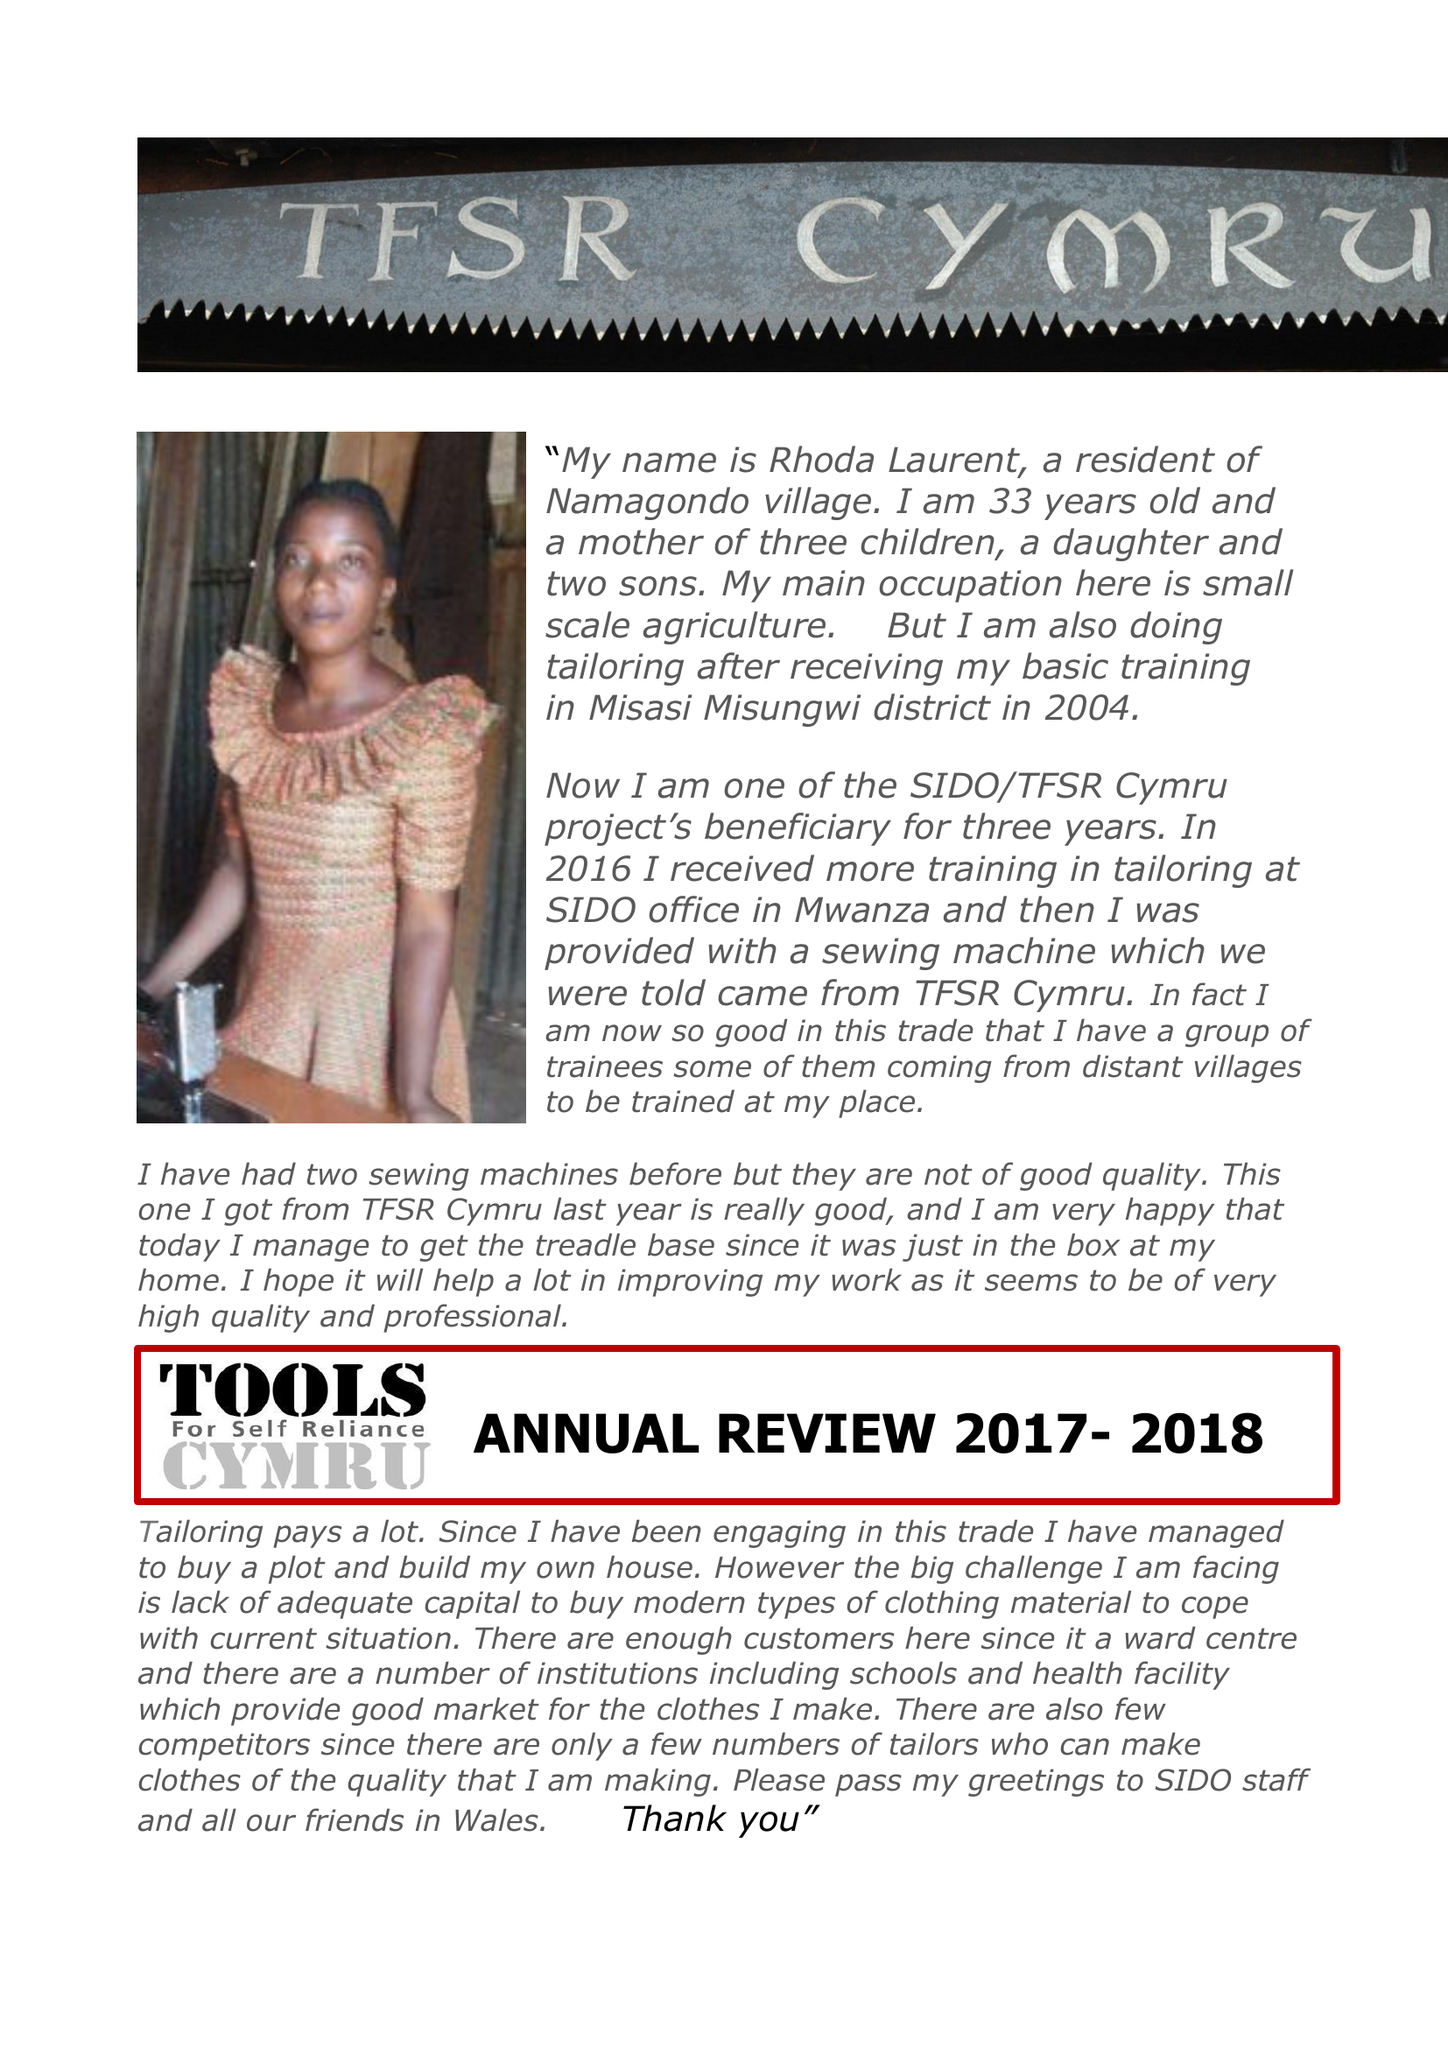What is the value for the spending_annually_in_british_pounds?
Answer the question using a single word or phrase. 68469.00 